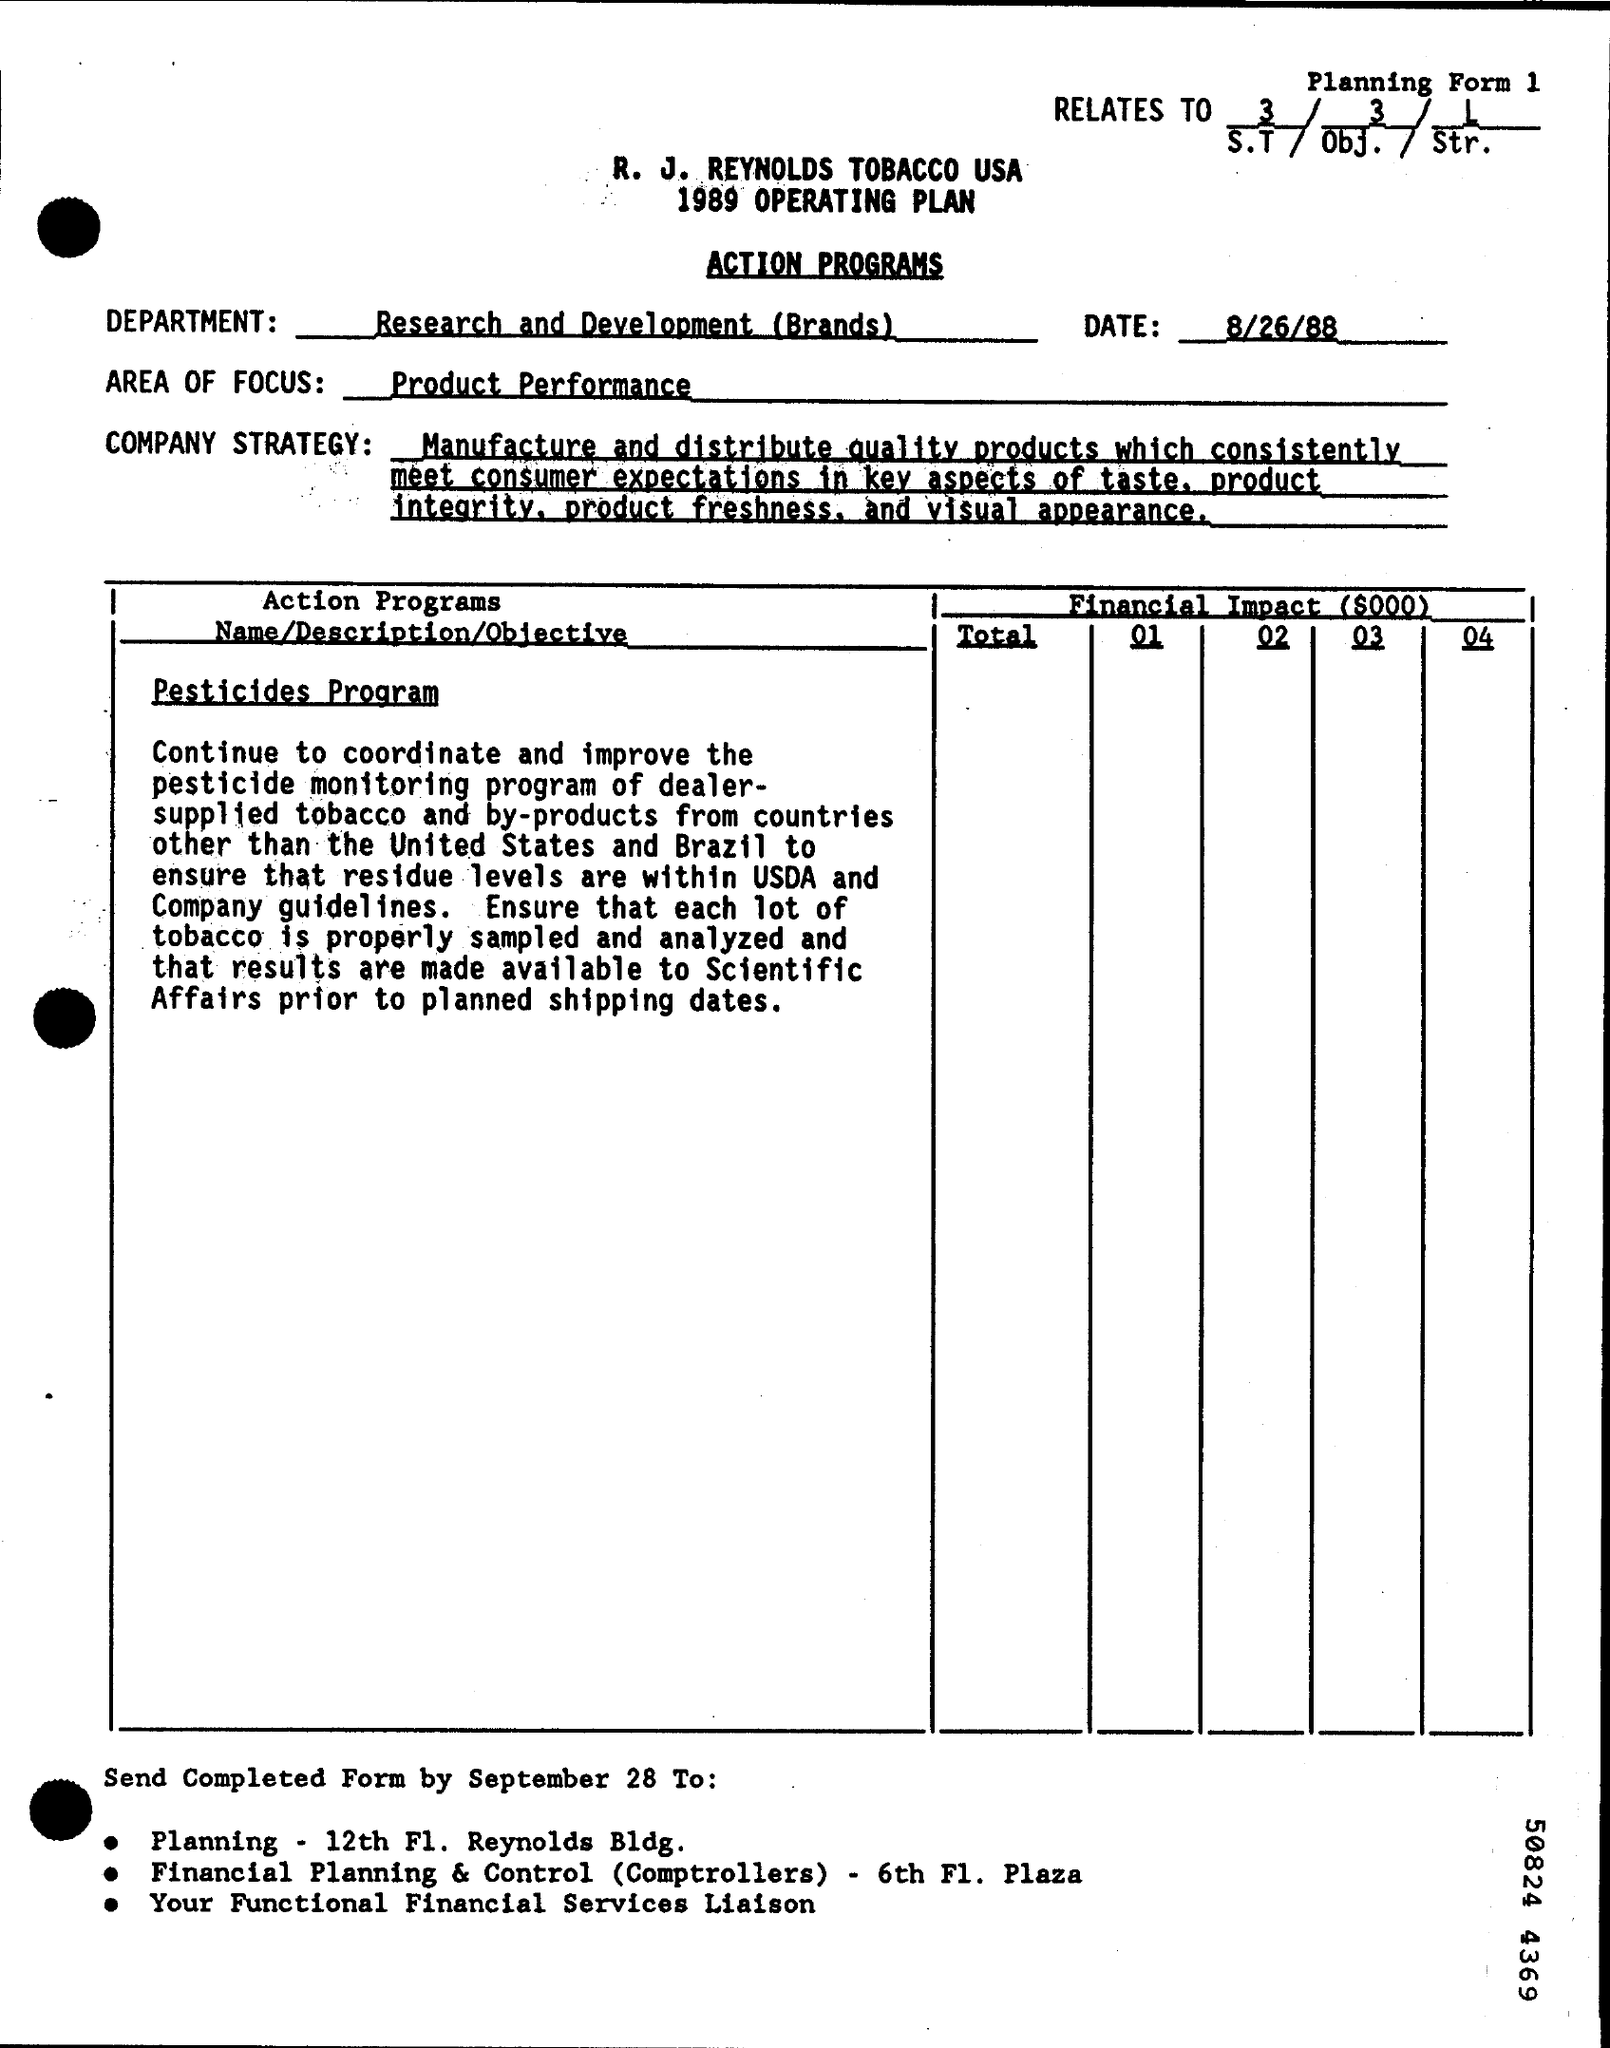What is the Department Name  ?
Keep it short and to the point. Research and Development (Brands). When is the Memorandum dated on ?
Ensure brevity in your answer.  8/26/88. What is written in the AREA OF FOCUS Field ?
Give a very brief answer. Product performance. 